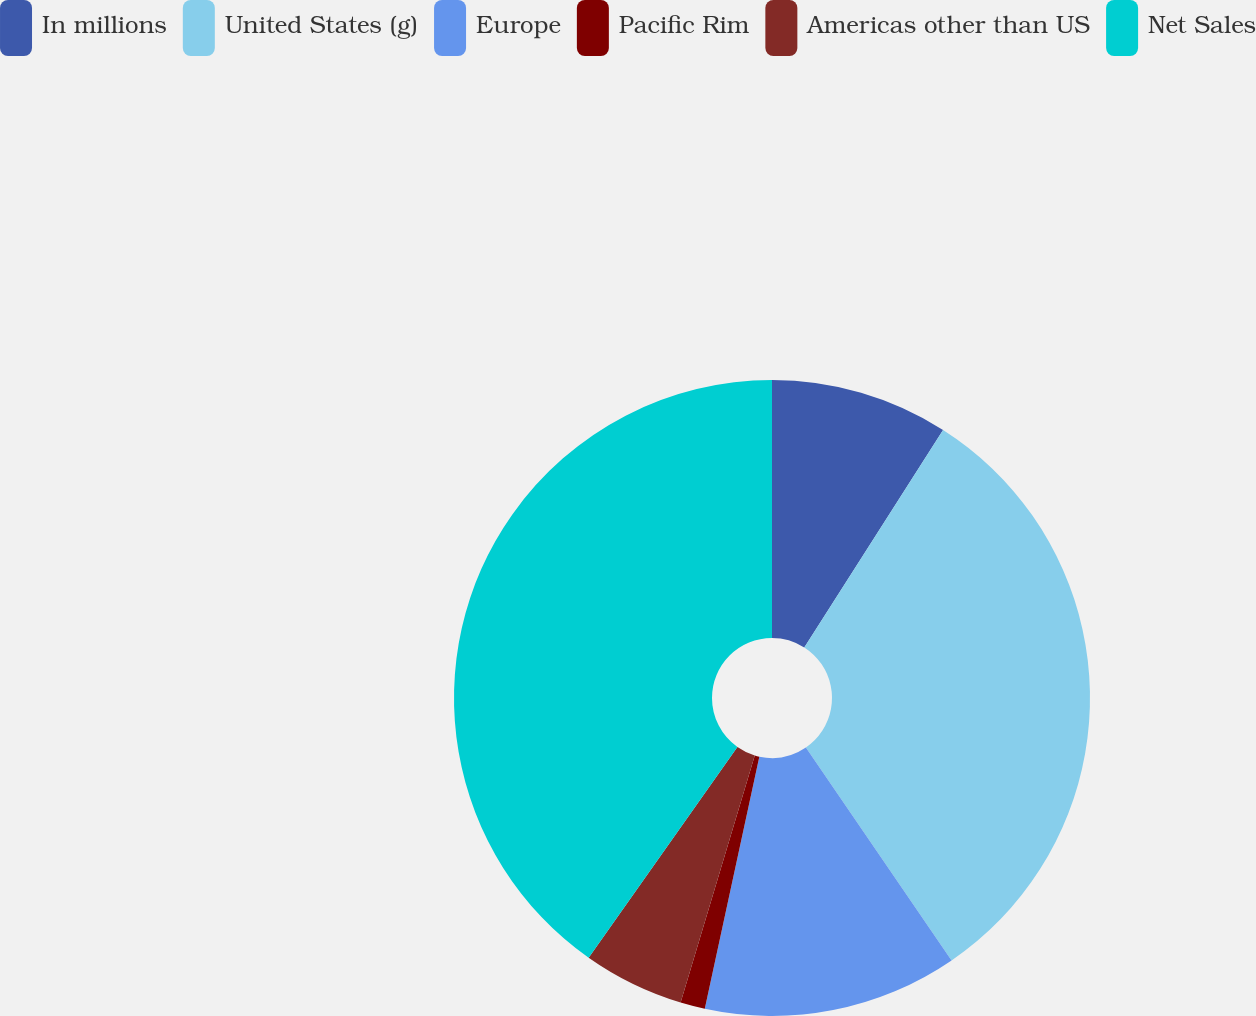<chart> <loc_0><loc_0><loc_500><loc_500><pie_chart><fcel>In millions<fcel>United States (g)<fcel>Europe<fcel>Pacific Rim<fcel>Americas other than US<fcel>Net Sales<nl><fcel>9.04%<fcel>31.41%<fcel>12.94%<fcel>1.25%<fcel>5.14%<fcel>40.22%<nl></chart> 